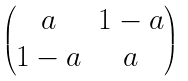Convert formula to latex. <formula><loc_0><loc_0><loc_500><loc_500>\begin{pmatrix} a & 1 - a \\ 1 - a & a \end{pmatrix}</formula> 